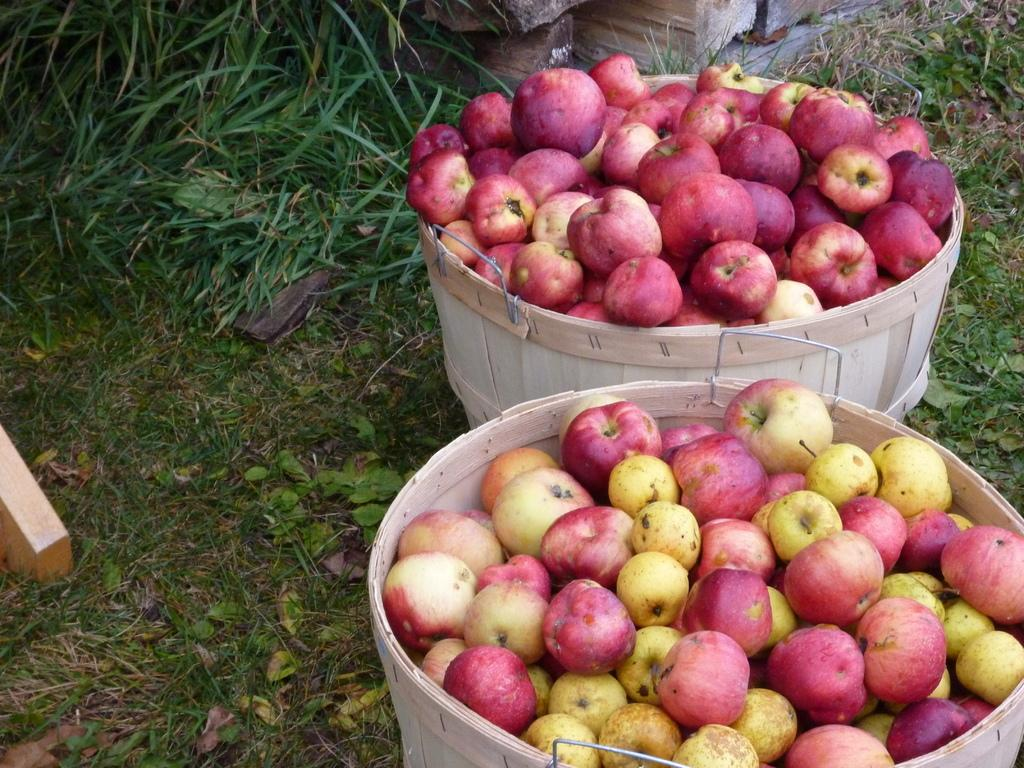What type of fruit is present in the image? There are many apples in the image. How are the apples stored or displayed in the image? The apples are kept in baskets. What type of surface is visible at the bottom of the image? There is green grass at the bottom of the image. What type of bedroom furniture can be seen in the image? There is no bedroom furniture present in the image, as it primarily features apples in baskets and green grass. 